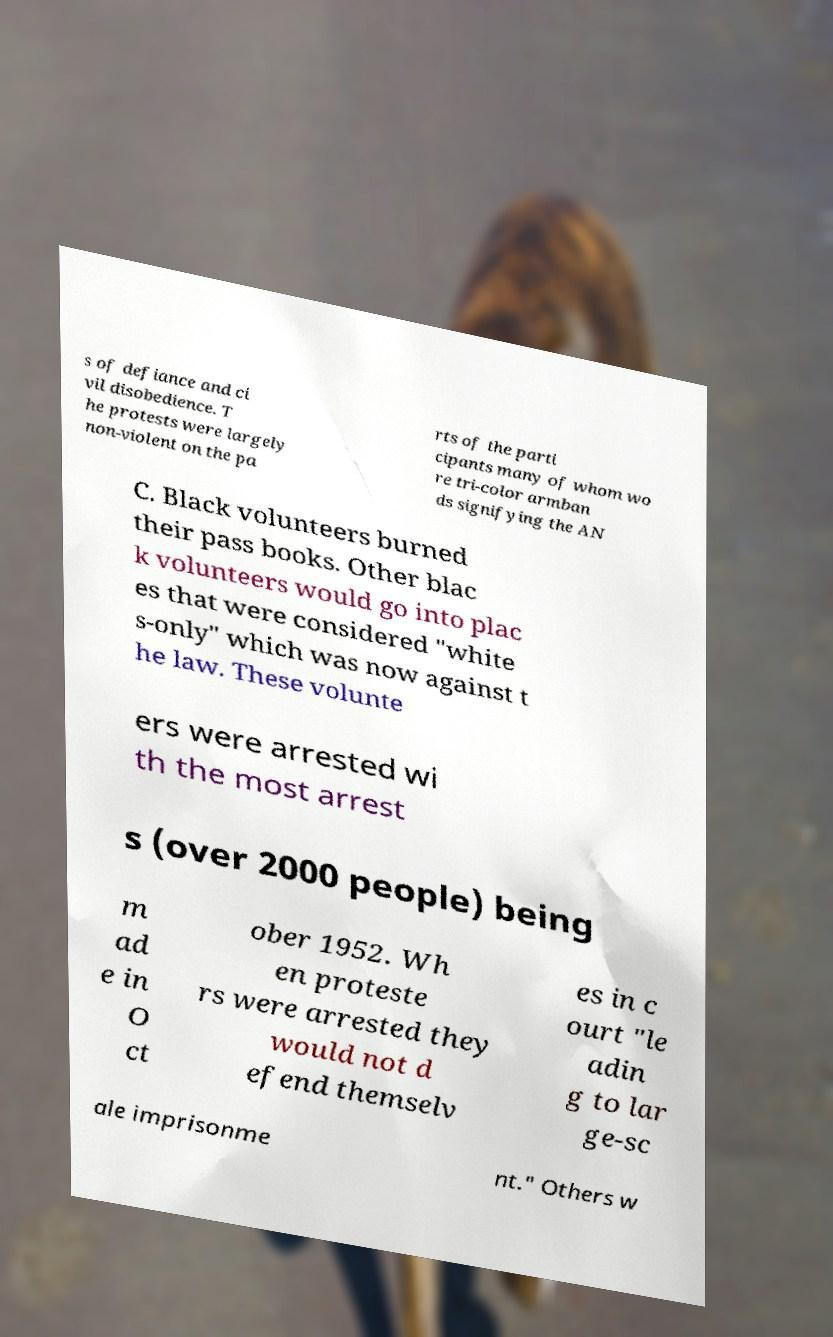Please identify and transcribe the text found in this image. s of defiance and ci vil disobedience. T he protests were largely non-violent on the pa rts of the parti cipants many of whom wo re tri-color armban ds signifying the AN C. Black volunteers burned their pass books. Other blac k volunteers would go into plac es that were considered "white s-only" which was now against t he law. These volunte ers were arrested wi th the most arrest s (over 2000 people) being m ad e in O ct ober 1952. Wh en proteste rs were arrested they would not d efend themselv es in c ourt "le adin g to lar ge-sc ale imprisonme nt." Others w 